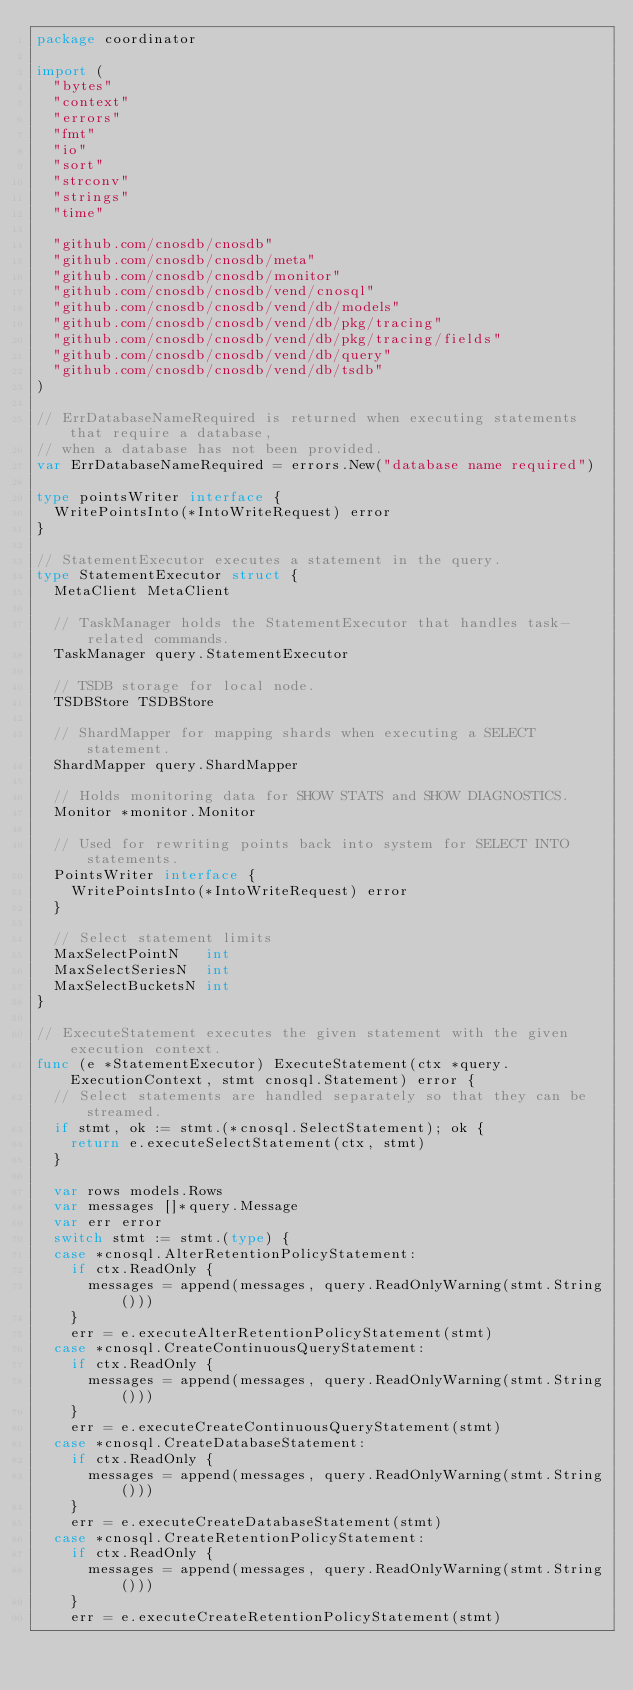Convert code to text. <code><loc_0><loc_0><loc_500><loc_500><_Go_>package coordinator

import (
	"bytes"
	"context"
	"errors"
	"fmt"
	"io"
	"sort"
	"strconv"
	"strings"
	"time"

	"github.com/cnosdb/cnosdb"
	"github.com/cnosdb/cnosdb/meta"
	"github.com/cnosdb/cnosdb/monitor"
	"github.com/cnosdb/cnosdb/vend/cnosql"
	"github.com/cnosdb/cnosdb/vend/db/models"
	"github.com/cnosdb/cnosdb/vend/db/pkg/tracing"
	"github.com/cnosdb/cnosdb/vend/db/pkg/tracing/fields"
	"github.com/cnosdb/cnosdb/vend/db/query"
	"github.com/cnosdb/cnosdb/vend/db/tsdb"
)

// ErrDatabaseNameRequired is returned when executing statements that require a database,
// when a database has not been provided.
var ErrDatabaseNameRequired = errors.New("database name required")

type pointsWriter interface {
	WritePointsInto(*IntoWriteRequest) error
}

// StatementExecutor executes a statement in the query.
type StatementExecutor struct {
	MetaClient MetaClient

	// TaskManager holds the StatementExecutor that handles task-related commands.
	TaskManager query.StatementExecutor

	// TSDB storage for local node.
	TSDBStore TSDBStore

	// ShardMapper for mapping shards when executing a SELECT statement.
	ShardMapper query.ShardMapper

	// Holds monitoring data for SHOW STATS and SHOW DIAGNOSTICS.
	Monitor *monitor.Monitor

	// Used for rewriting points back into system for SELECT INTO statements.
	PointsWriter interface {
		WritePointsInto(*IntoWriteRequest) error
	}

	// Select statement limits
	MaxSelectPointN   int
	MaxSelectSeriesN  int
	MaxSelectBucketsN int
}

// ExecuteStatement executes the given statement with the given execution context.
func (e *StatementExecutor) ExecuteStatement(ctx *query.ExecutionContext, stmt cnosql.Statement) error {
	// Select statements are handled separately so that they can be streamed.
	if stmt, ok := stmt.(*cnosql.SelectStatement); ok {
		return e.executeSelectStatement(ctx, stmt)
	}

	var rows models.Rows
	var messages []*query.Message
	var err error
	switch stmt := stmt.(type) {
	case *cnosql.AlterRetentionPolicyStatement:
		if ctx.ReadOnly {
			messages = append(messages, query.ReadOnlyWarning(stmt.String()))
		}
		err = e.executeAlterRetentionPolicyStatement(stmt)
	case *cnosql.CreateContinuousQueryStatement:
		if ctx.ReadOnly {
			messages = append(messages, query.ReadOnlyWarning(stmt.String()))
		}
		err = e.executeCreateContinuousQueryStatement(stmt)
	case *cnosql.CreateDatabaseStatement:
		if ctx.ReadOnly {
			messages = append(messages, query.ReadOnlyWarning(stmt.String()))
		}
		err = e.executeCreateDatabaseStatement(stmt)
	case *cnosql.CreateRetentionPolicyStatement:
		if ctx.ReadOnly {
			messages = append(messages, query.ReadOnlyWarning(stmt.String()))
		}
		err = e.executeCreateRetentionPolicyStatement(stmt)</code> 